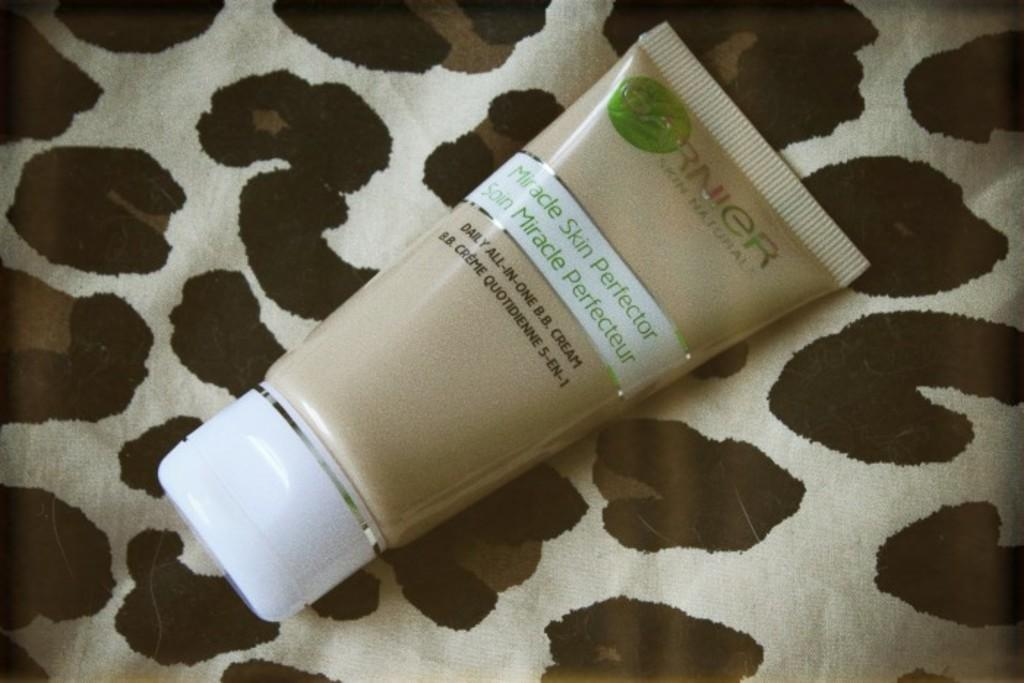<image>
Share a concise interpretation of the image provided. A tube of Miracle Skin Perfector sitting on top of a brown and white table cloth. 